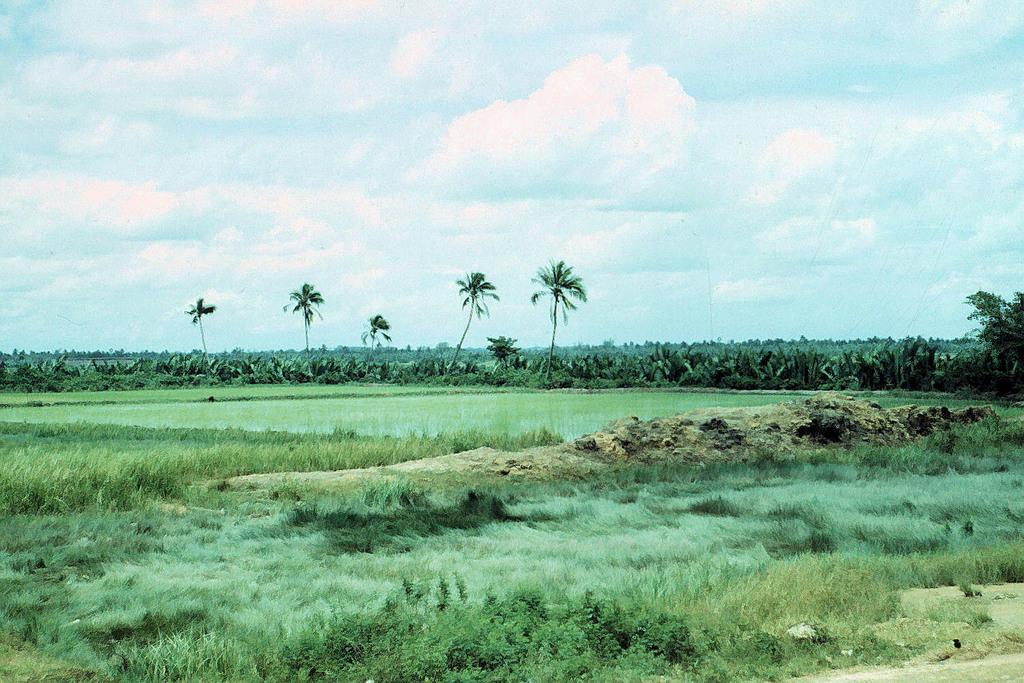How would you summarize this image in a sentence or two? In this image there are plants, trees, grass and cloudy sky. 